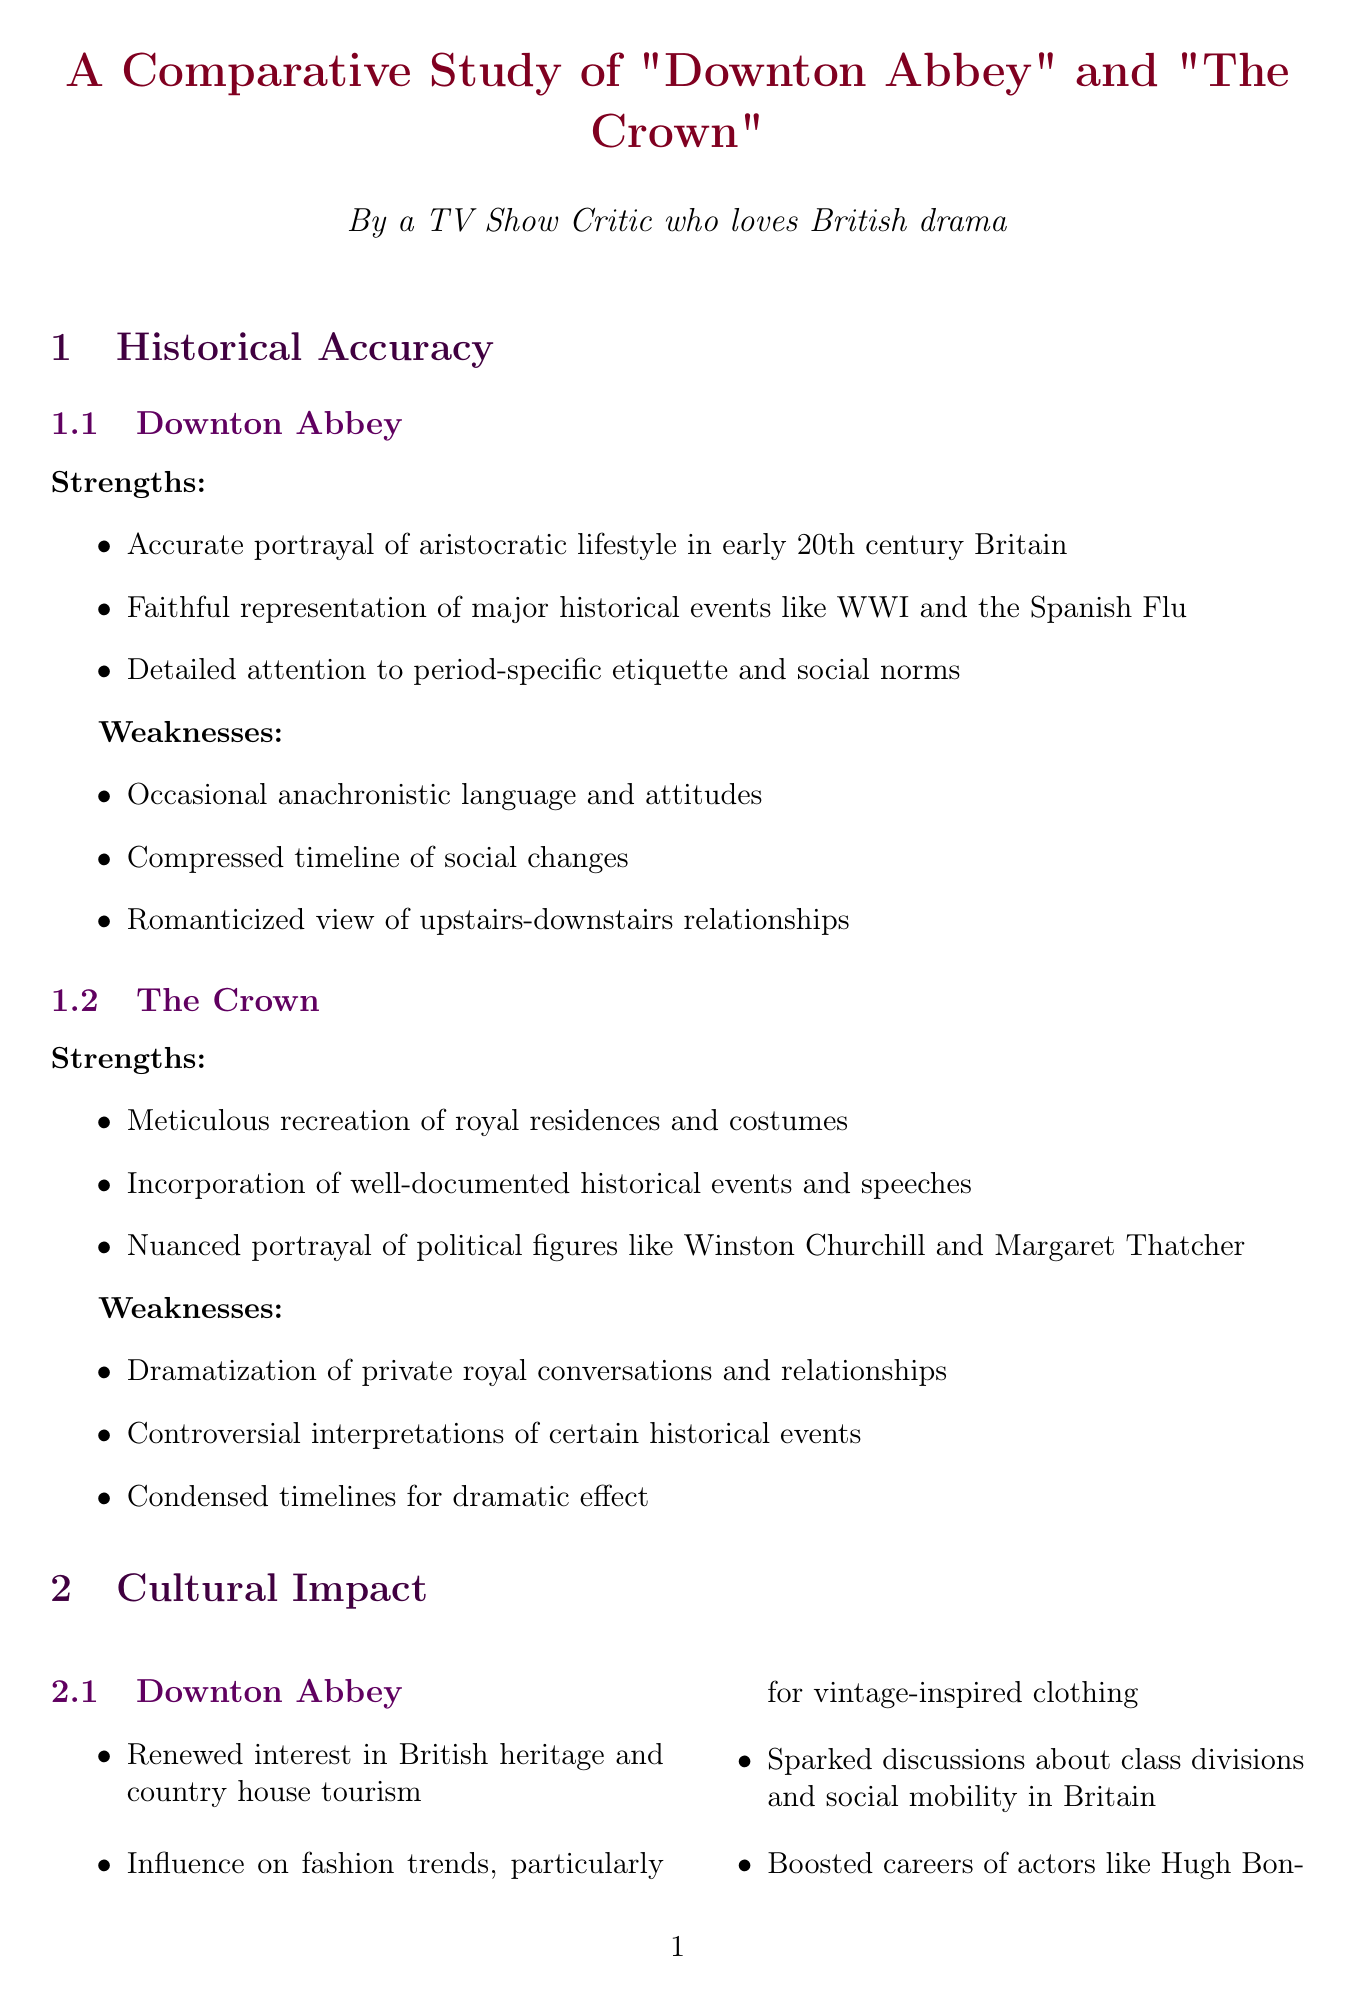What is the location used for "Downton Abbey" set design? The document specifies that "Downton Abbey" was filmed at Highclere Castle.
Answer: Highclere Castle What major historical event is accurately portrayed in "Downton Abbey"? One of the strengths listed is the faithful representation of major historical events like WWI.
Answer: WWI Which designer worked on "The Crown" costumes in Seasons 1-2? The document states that Michele Clapton was the designer for Seasons 1-2 of "The Crown."
Answer: Michele Clapton What impact did "The Crown" have on public interest? It mentions that "The Crown" increased public interest in the British Royal Family.
Answer: Increased public interest in the British Royal Family How many awards did "Downton Abbey" win at the Golden Globe? The document records one win at the Golden Globe for Best Miniseries or Television Film in 2012.
Answer: One What is a weakness of "The Crown" related to historical events? It notes that "The Crown" involves controversial interpretations of certain historical events.
Answer: Controversial interpretations of certain historical events Which actor's career did "Downton Abbey" boost? The document highlights that it boosted the career of actors like Hugh Bonneville.
Answer: Hugh Bonneville What was a notable critique of "Downton Abbey" according to critics? Critics mentioned that "Downton Abbey" occasionally falls into soap opera territory.
Answer: Occasionally falls into soap opera territory 